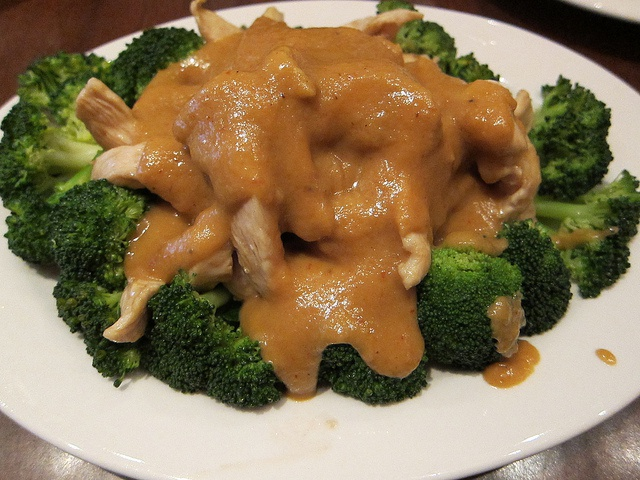Describe the objects in this image and their specific colors. I can see broccoli in black, darkgreen, and olive tones, broccoli in black, darkgreen, and olive tones, and broccoli in black, olive, and darkgreen tones in this image. 